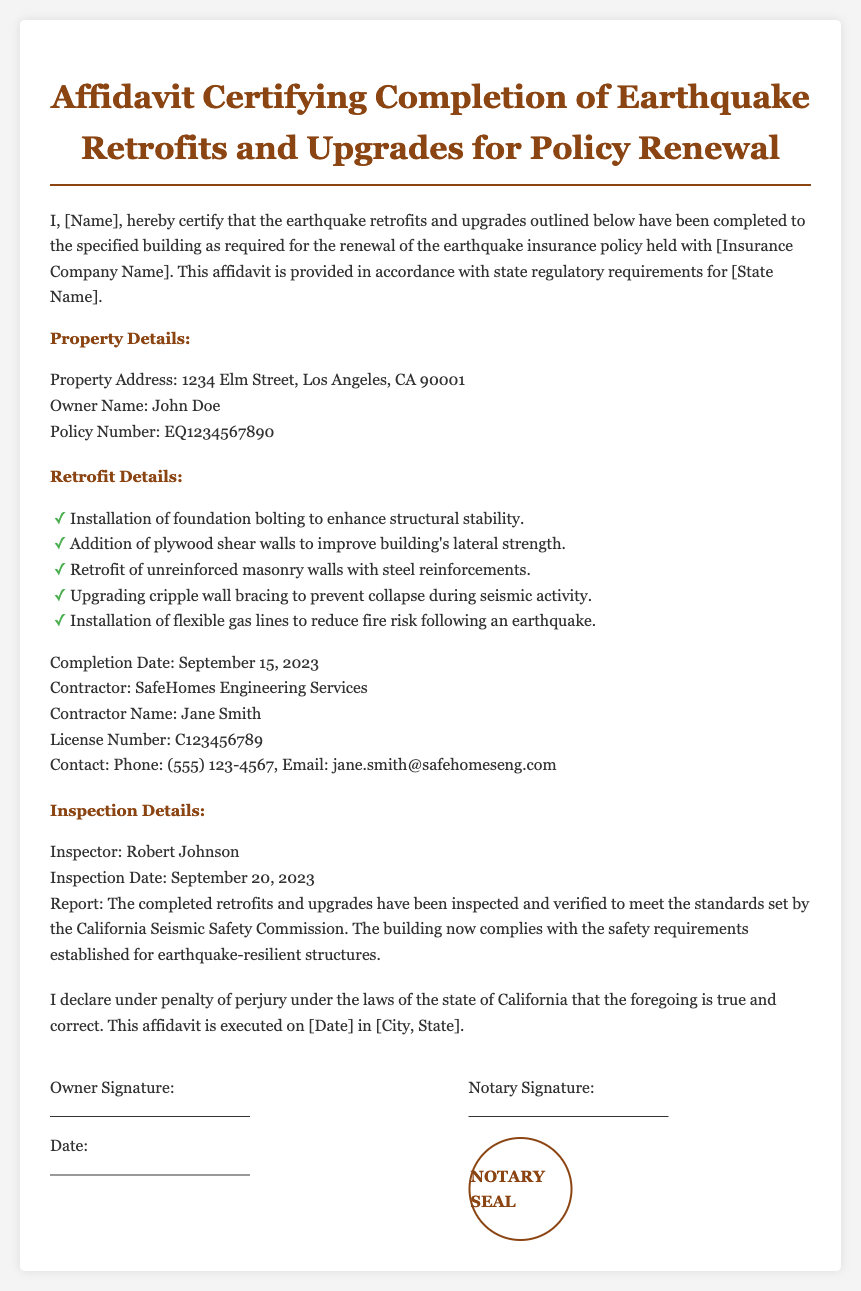What is the property address? The property address is listed under the Property Details section in the document.
Answer: 1234 Elm Street, Los Angeles, CA 90001 Who is the owner of the property? The owner's name is mentioned in the Property Details section.
Answer: John Doe What is the completion date of the retrofits? The completion date is provided in the Retrofit Details section.
Answer: September 15, 2023 Who inspected the retrofits? The inspector’s name is indicated in the Inspection Details section of the document.
Answer: Robert Johnson What is the contractor's name? The contractor's name is specified in the Retrofit Details section.
Answer: Jane Smith 